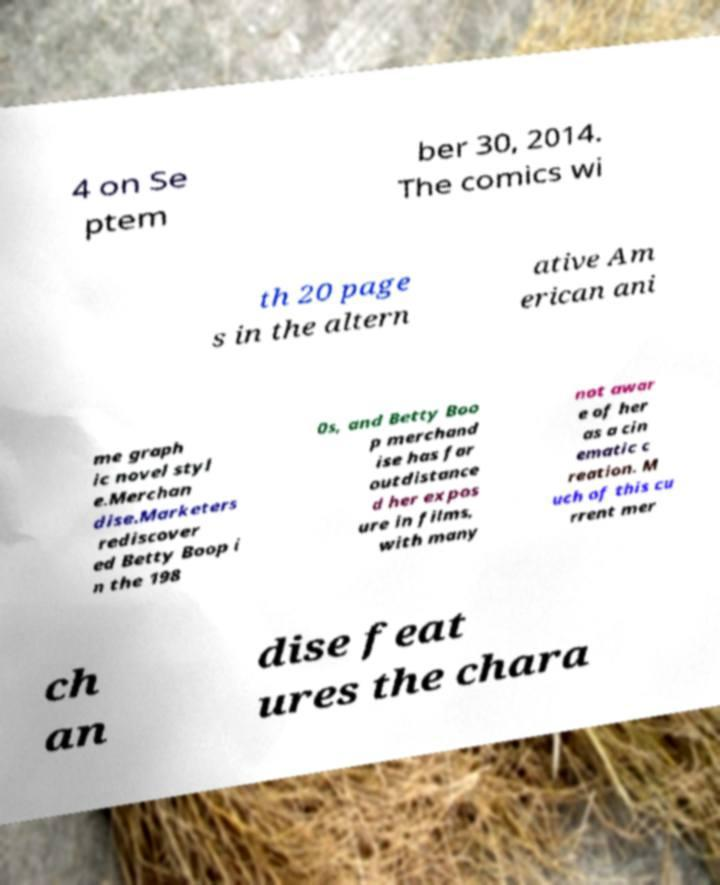What messages or text are displayed in this image? I need them in a readable, typed format. 4 on Se ptem ber 30, 2014. The comics wi th 20 page s in the altern ative Am erican ani me graph ic novel styl e.Merchan dise.Marketers rediscover ed Betty Boop i n the 198 0s, and Betty Boo p merchand ise has far outdistance d her expos ure in films, with many not awar e of her as a cin ematic c reation. M uch of this cu rrent mer ch an dise feat ures the chara 